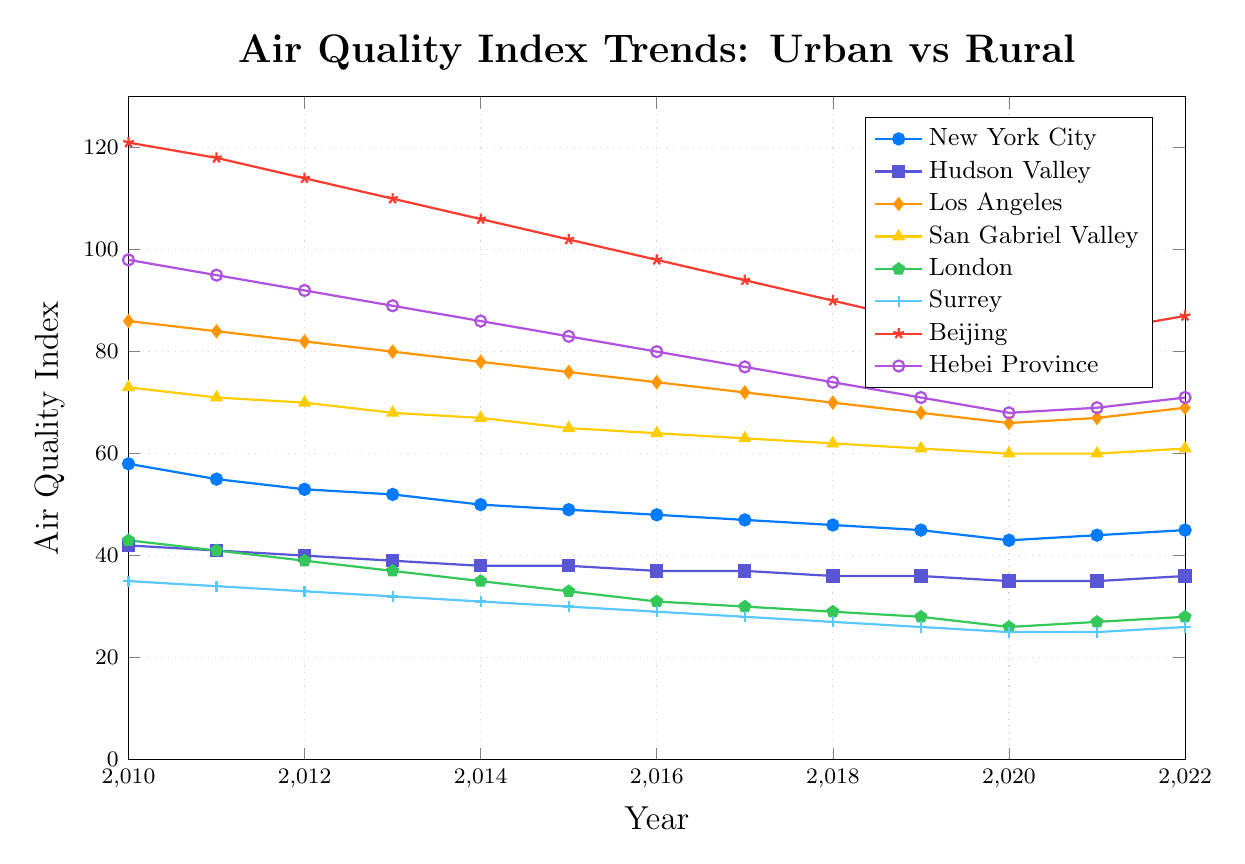What is the trend in air quality in New York City from 2010 to 2022? To determine the trend in New York City's air quality, observe the line representing New York City in the plot. Notice the general direction and slope of the line over the years. The air quality index starts at 58 in 2010 and generally decreases to 45 in 2022, with a slight uptick in the last two years.
Answer: The air quality in New York City shows a downward trend How does the air quality of Beijing in 2022 compare to that of Hebei Province in the same year? Locate the points for Beijing and Hebei Province in 2022 on the chart. Beijing has a value of 87, while Hebei Province has a value of 71.
Answer: Beijing's air quality index is higher than Hebei Province's in 2022 Which city or region has the lowest air quality index value in 2020? Identify the air quality index values for all cities and regions for the year 2020. Compare these values to find the lowest one. Surrey has a value of 25, which is the lowest.
Answer: Surrey What is the average air quality index for Los Angeles from 2010 to 2015? First, sum the values from 2010 to 2015 for Los Angeles: 86, 84, 82, 80, 78, 76. Then divide by the number of years (6). (86 + 84 + 82 + 80 + 78 + 76) / 6 = 81.
Answer: 81 How much did the air quality improve in London from 2010 to 2020? Find the air quality index values for London in 2010 (43) and 2020 (26). Calculate the difference by subtracting the 2020 value from the 2010 value: 43 - 26 = 17.
Answer: 17 Which has a greater improvement in air quality from 2010 to 2022, Beijing or Los Angeles? Find the air quality index values for Beijing and Los Angeles in both 2010 and 2022. For Beijing, the values are 121 in 2010 and 87 in 2022. For Los Angeles, the values are 86 in 2010 and 69 in 2022. Calculate the difference for each: Beijing: 121 - 87 = 34, Los Angeles: 86 - 69 = 17. Beijing shows a greater improvement.
Answer: Beijing Compare the air quality index of New York City and Hudson Valley in 2014. Which one has a better air quality? Locate the air quality index values for New York City (50) and Hudson Valley (38) in 2014. The lower value indicates better air quality.
Answer: Hudson Valley has better air quality What is the percentage decrease in air quality index for San Gabriel Valley from 2010 to 2019? Find the air quality index values for San Gabriel Valley in 2010 (73) and 2019 (61). Calculate the difference: 73 - 61 = 12. Then, find the percentage decrease: (12 / 73) * 100 ≈ 16.44%.
Answer: Approximately 16.44% Of all the regions, which one shows the least change in air quality index from 2010 to 2022? Compare the difference in air quality index values from 2010 to 2022 for all regions. Calculate the difference for each region and identify the smallest change. For New York City: 45-58 = -13; Hudson Valley: 36-42 = -6; Los Angeles: 69-86 = -17; San Gabriel Valley: 61-73 = -12; London: 28-43 = -15; Surrey: 26-35 = -9; Beijing: 87-121 = -34; Hebei Province: 71-98 = -27. Hudson Valley shows the least change.
Answer: Hudson Valley 